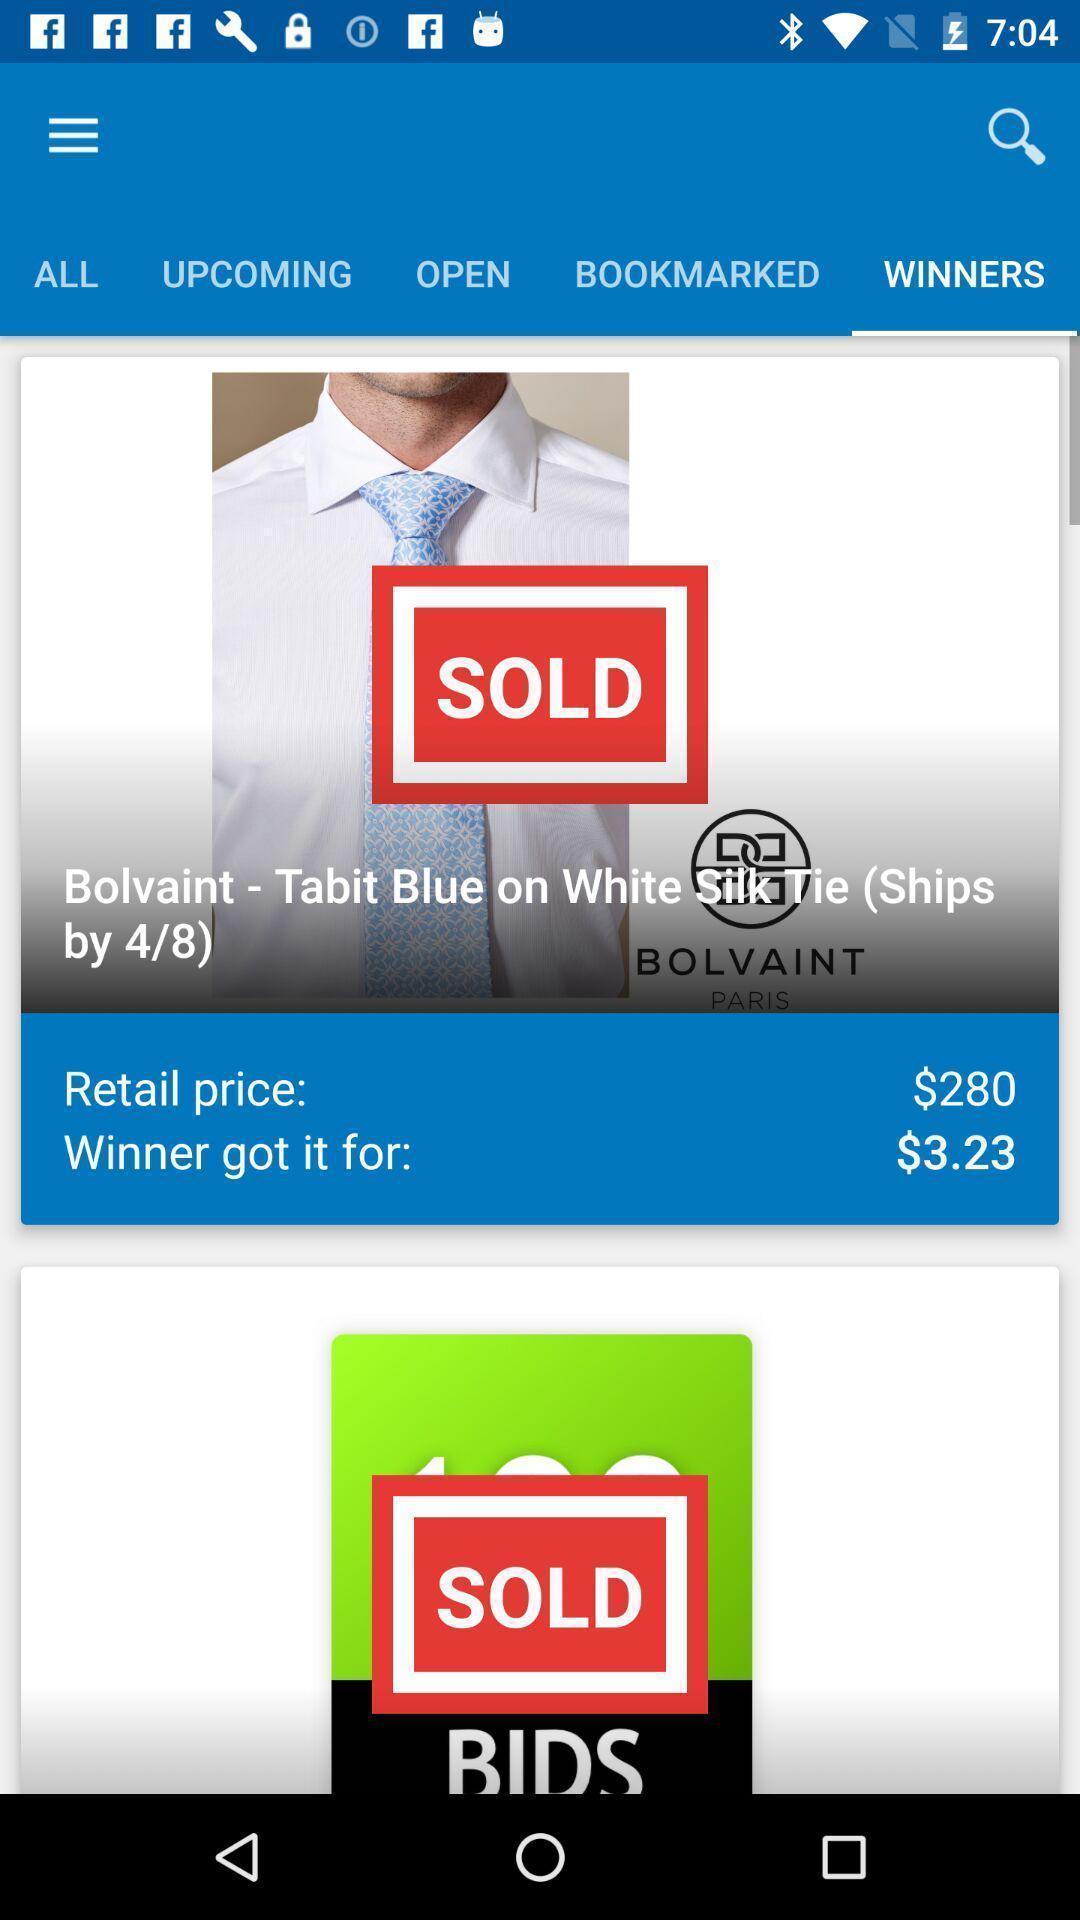Explain the elements present in this screenshot. Screen shows multiple options in a shopping application. 